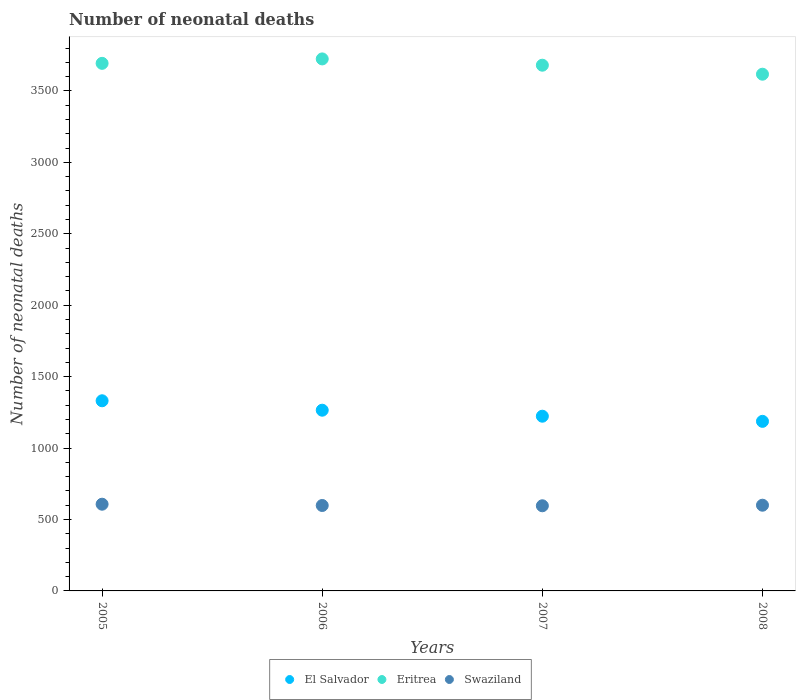Is the number of dotlines equal to the number of legend labels?
Give a very brief answer. Yes. What is the number of neonatal deaths in in Swaziland in 2005?
Your answer should be compact. 607. Across all years, what is the maximum number of neonatal deaths in in El Salvador?
Make the answer very short. 1331. Across all years, what is the minimum number of neonatal deaths in in Eritrea?
Your response must be concise. 3617. In which year was the number of neonatal deaths in in Eritrea maximum?
Provide a succinct answer. 2006. In which year was the number of neonatal deaths in in Swaziland minimum?
Offer a terse response. 2007. What is the total number of neonatal deaths in in El Salvador in the graph?
Provide a succinct answer. 5006. What is the difference between the number of neonatal deaths in in El Salvador in 2006 and that in 2008?
Offer a terse response. 78. What is the difference between the number of neonatal deaths in in Eritrea in 2006 and the number of neonatal deaths in in El Salvador in 2007?
Make the answer very short. 2501. What is the average number of neonatal deaths in in Eritrea per year?
Your answer should be compact. 3678.5. In the year 2005, what is the difference between the number of neonatal deaths in in Eritrea and number of neonatal deaths in in El Salvador?
Your answer should be very brief. 2362. What is the ratio of the number of neonatal deaths in in El Salvador in 2005 to that in 2006?
Give a very brief answer. 1.05. What is the difference between the highest and the lowest number of neonatal deaths in in Eritrea?
Make the answer very short. 107. In how many years, is the number of neonatal deaths in in El Salvador greater than the average number of neonatal deaths in in El Salvador taken over all years?
Your response must be concise. 2. Does the number of neonatal deaths in in Swaziland monotonically increase over the years?
Make the answer very short. No. Is the number of neonatal deaths in in El Salvador strictly less than the number of neonatal deaths in in Swaziland over the years?
Your response must be concise. No. How many dotlines are there?
Provide a short and direct response. 3. What is the difference between two consecutive major ticks on the Y-axis?
Keep it short and to the point. 500. Are the values on the major ticks of Y-axis written in scientific E-notation?
Make the answer very short. No. Does the graph contain any zero values?
Provide a succinct answer. No. Where does the legend appear in the graph?
Ensure brevity in your answer.  Bottom center. How many legend labels are there?
Make the answer very short. 3. What is the title of the graph?
Provide a succinct answer. Number of neonatal deaths. Does "Georgia" appear as one of the legend labels in the graph?
Provide a succinct answer. No. What is the label or title of the Y-axis?
Offer a very short reply. Number of neonatal deaths. What is the Number of neonatal deaths in El Salvador in 2005?
Provide a short and direct response. 1331. What is the Number of neonatal deaths in Eritrea in 2005?
Keep it short and to the point. 3693. What is the Number of neonatal deaths in Swaziland in 2005?
Keep it short and to the point. 607. What is the Number of neonatal deaths in El Salvador in 2006?
Give a very brief answer. 1265. What is the Number of neonatal deaths in Eritrea in 2006?
Provide a short and direct response. 3724. What is the Number of neonatal deaths of Swaziland in 2006?
Offer a very short reply. 598. What is the Number of neonatal deaths in El Salvador in 2007?
Offer a very short reply. 1223. What is the Number of neonatal deaths in Eritrea in 2007?
Offer a very short reply. 3680. What is the Number of neonatal deaths of Swaziland in 2007?
Your answer should be compact. 596. What is the Number of neonatal deaths in El Salvador in 2008?
Provide a short and direct response. 1187. What is the Number of neonatal deaths in Eritrea in 2008?
Your answer should be compact. 3617. What is the Number of neonatal deaths of Swaziland in 2008?
Offer a terse response. 600. Across all years, what is the maximum Number of neonatal deaths in El Salvador?
Make the answer very short. 1331. Across all years, what is the maximum Number of neonatal deaths of Eritrea?
Provide a short and direct response. 3724. Across all years, what is the maximum Number of neonatal deaths in Swaziland?
Make the answer very short. 607. Across all years, what is the minimum Number of neonatal deaths in El Salvador?
Provide a succinct answer. 1187. Across all years, what is the minimum Number of neonatal deaths of Eritrea?
Offer a terse response. 3617. Across all years, what is the minimum Number of neonatal deaths of Swaziland?
Offer a terse response. 596. What is the total Number of neonatal deaths of El Salvador in the graph?
Provide a succinct answer. 5006. What is the total Number of neonatal deaths in Eritrea in the graph?
Make the answer very short. 1.47e+04. What is the total Number of neonatal deaths in Swaziland in the graph?
Your answer should be compact. 2401. What is the difference between the Number of neonatal deaths of El Salvador in 2005 and that in 2006?
Your answer should be very brief. 66. What is the difference between the Number of neonatal deaths of Eritrea in 2005 and that in 2006?
Ensure brevity in your answer.  -31. What is the difference between the Number of neonatal deaths of El Salvador in 2005 and that in 2007?
Ensure brevity in your answer.  108. What is the difference between the Number of neonatal deaths in Eritrea in 2005 and that in 2007?
Provide a short and direct response. 13. What is the difference between the Number of neonatal deaths in Swaziland in 2005 and that in 2007?
Ensure brevity in your answer.  11. What is the difference between the Number of neonatal deaths in El Salvador in 2005 and that in 2008?
Offer a terse response. 144. What is the difference between the Number of neonatal deaths of Swaziland in 2006 and that in 2007?
Ensure brevity in your answer.  2. What is the difference between the Number of neonatal deaths of El Salvador in 2006 and that in 2008?
Provide a succinct answer. 78. What is the difference between the Number of neonatal deaths of Eritrea in 2006 and that in 2008?
Your answer should be very brief. 107. What is the difference between the Number of neonatal deaths of El Salvador in 2007 and that in 2008?
Provide a succinct answer. 36. What is the difference between the Number of neonatal deaths in El Salvador in 2005 and the Number of neonatal deaths in Eritrea in 2006?
Your answer should be very brief. -2393. What is the difference between the Number of neonatal deaths in El Salvador in 2005 and the Number of neonatal deaths in Swaziland in 2006?
Your answer should be compact. 733. What is the difference between the Number of neonatal deaths of Eritrea in 2005 and the Number of neonatal deaths of Swaziland in 2006?
Your answer should be very brief. 3095. What is the difference between the Number of neonatal deaths of El Salvador in 2005 and the Number of neonatal deaths of Eritrea in 2007?
Your answer should be compact. -2349. What is the difference between the Number of neonatal deaths in El Salvador in 2005 and the Number of neonatal deaths in Swaziland in 2007?
Offer a very short reply. 735. What is the difference between the Number of neonatal deaths of Eritrea in 2005 and the Number of neonatal deaths of Swaziland in 2007?
Ensure brevity in your answer.  3097. What is the difference between the Number of neonatal deaths in El Salvador in 2005 and the Number of neonatal deaths in Eritrea in 2008?
Offer a very short reply. -2286. What is the difference between the Number of neonatal deaths in El Salvador in 2005 and the Number of neonatal deaths in Swaziland in 2008?
Provide a succinct answer. 731. What is the difference between the Number of neonatal deaths in Eritrea in 2005 and the Number of neonatal deaths in Swaziland in 2008?
Give a very brief answer. 3093. What is the difference between the Number of neonatal deaths of El Salvador in 2006 and the Number of neonatal deaths of Eritrea in 2007?
Make the answer very short. -2415. What is the difference between the Number of neonatal deaths in El Salvador in 2006 and the Number of neonatal deaths in Swaziland in 2007?
Your answer should be compact. 669. What is the difference between the Number of neonatal deaths in Eritrea in 2006 and the Number of neonatal deaths in Swaziland in 2007?
Make the answer very short. 3128. What is the difference between the Number of neonatal deaths of El Salvador in 2006 and the Number of neonatal deaths of Eritrea in 2008?
Provide a succinct answer. -2352. What is the difference between the Number of neonatal deaths of El Salvador in 2006 and the Number of neonatal deaths of Swaziland in 2008?
Your answer should be compact. 665. What is the difference between the Number of neonatal deaths of Eritrea in 2006 and the Number of neonatal deaths of Swaziland in 2008?
Provide a succinct answer. 3124. What is the difference between the Number of neonatal deaths of El Salvador in 2007 and the Number of neonatal deaths of Eritrea in 2008?
Ensure brevity in your answer.  -2394. What is the difference between the Number of neonatal deaths in El Salvador in 2007 and the Number of neonatal deaths in Swaziland in 2008?
Your response must be concise. 623. What is the difference between the Number of neonatal deaths in Eritrea in 2007 and the Number of neonatal deaths in Swaziland in 2008?
Your answer should be very brief. 3080. What is the average Number of neonatal deaths of El Salvador per year?
Make the answer very short. 1251.5. What is the average Number of neonatal deaths of Eritrea per year?
Provide a succinct answer. 3678.5. What is the average Number of neonatal deaths in Swaziland per year?
Your answer should be very brief. 600.25. In the year 2005, what is the difference between the Number of neonatal deaths of El Salvador and Number of neonatal deaths of Eritrea?
Give a very brief answer. -2362. In the year 2005, what is the difference between the Number of neonatal deaths of El Salvador and Number of neonatal deaths of Swaziland?
Make the answer very short. 724. In the year 2005, what is the difference between the Number of neonatal deaths in Eritrea and Number of neonatal deaths in Swaziland?
Your answer should be very brief. 3086. In the year 2006, what is the difference between the Number of neonatal deaths in El Salvador and Number of neonatal deaths in Eritrea?
Ensure brevity in your answer.  -2459. In the year 2006, what is the difference between the Number of neonatal deaths of El Salvador and Number of neonatal deaths of Swaziland?
Ensure brevity in your answer.  667. In the year 2006, what is the difference between the Number of neonatal deaths of Eritrea and Number of neonatal deaths of Swaziland?
Provide a short and direct response. 3126. In the year 2007, what is the difference between the Number of neonatal deaths of El Salvador and Number of neonatal deaths of Eritrea?
Keep it short and to the point. -2457. In the year 2007, what is the difference between the Number of neonatal deaths in El Salvador and Number of neonatal deaths in Swaziland?
Ensure brevity in your answer.  627. In the year 2007, what is the difference between the Number of neonatal deaths in Eritrea and Number of neonatal deaths in Swaziland?
Your answer should be very brief. 3084. In the year 2008, what is the difference between the Number of neonatal deaths in El Salvador and Number of neonatal deaths in Eritrea?
Your answer should be very brief. -2430. In the year 2008, what is the difference between the Number of neonatal deaths of El Salvador and Number of neonatal deaths of Swaziland?
Your answer should be very brief. 587. In the year 2008, what is the difference between the Number of neonatal deaths in Eritrea and Number of neonatal deaths in Swaziland?
Ensure brevity in your answer.  3017. What is the ratio of the Number of neonatal deaths of El Salvador in 2005 to that in 2006?
Give a very brief answer. 1.05. What is the ratio of the Number of neonatal deaths of Eritrea in 2005 to that in 2006?
Offer a very short reply. 0.99. What is the ratio of the Number of neonatal deaths of Swaziland in 2005 to that in 2006?
Keep it short and to the point. 1.02. What is the ratio of the Number of neonatal deaths in El Salvador in 2005 to that in 2007?
Offer a very short reply. 1.09. What is the ratio of the Number of neonatal deaths of Swaziland in 2005 to that in 2007?
Your answer should be compact. 1.02. What is the ratio of the Number of neonatal deaths of El Salvador in 2005 to that in 2008?
Offer a terse response. 1.12. What is the ratio of the Number of neonatal deaths in Swaziland in 2005 to that in 2008?
Make the answer very short. 1.01. What is the ratio of the Number of neonatal deaths in El Salvador in 2006 to that in 2007?
Your response must be concise. 1.03. What is the ratio of the Number of neonatal deaths of Swaziland in 2006 to that in 2007?
Keep it short and to the point. 1. What is the ratio of the Number of neonatal deaths of El Salvador in 2006 to that in 2008?
Provide a short and direct response. 1.07. What is the ratio of the Number of neonatal deaths of Eritrea in 2006 to that in 2008?
Offer a terse response. 1.03. What is the ratio of the Number of neonatal deaths in El Salvador in 2007 to that in 2008?
Your answer should be very brief. 1.03. What is the ratio of the Number of neonatal deaths in Eritrea in 2007 to that in 2008?
Offer a very short reply. 1.02. What is the difference between the highest and the second highest Number of neonatal deaths in Eritrea?
Ensure brevity in your answer.  31. What is the difference between the highest and the second highest Number of neonatal deaths of Swaziland?
Your answer should be compact. 7. What is the difference between the highest and the lowest Number of neonatal deaths of El Salvador?
Your response must be concise. 144. What is the difference between the highest and the lowest Number of neonatal deaths of Eritrea?
Keep it short and to the point. 107. 